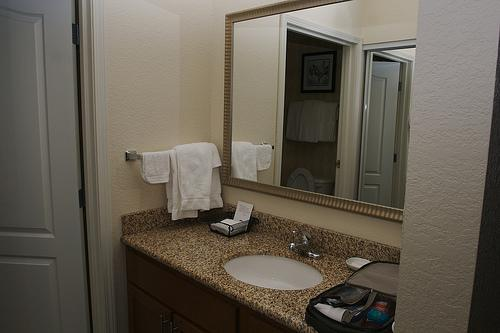Please give a brief overview of the key subject in the image and its associated objects. The key subject is the bathroom with an open white door, accompanied by a large mirror, a white ceramic sink, and assorted toiletries. Write a sentence giving an overview of the image’s primary subject and its accompanying elements. The primary subject is a bathroom with an open door, featuring a large mirror, white sink, and multiple bathroom items. Create a short sentence that summarizes the essential aspects of the picture. The picture presents a bright bathroom setting with an open door, a vast mirror, and various bathroom essentials. Mention the most prominent feature of this image in a concise statement. The picture showcases an open bathroom door with a wide framed mirror and numerous toiletries. What is the focal point of the image, and what are its primary components? The focal point is the bathroom with an open white door, a large mirror, white sink, and various toiletries. Briefly describe the image's core subject and related objects. The core subject is an opened bathroom door, surrounded by a sizable mirror, white sink, and several toiletries. Write a succinct description of the primary focus in the image and its key components. The primary focus is a bathroom area with an open door, showcasing a generous mirror, white sink, and an array of toiletries. Please provide a brief description of the primary object in the image. An opened white door is on the left side of the bathroom with a large mirror above a white ceramic sink and various toiletries. Identify the main element in the picture and describe its associated objects. The main element is the open bathroom door, surrounded by a large mirror, a white ceramic sink, and various toiletries. Compose a short sentence highlighting the central theme of the image. The image exhibits an airy bathroom featuring a white door, a sizable mirror, and bathroom essentials. 